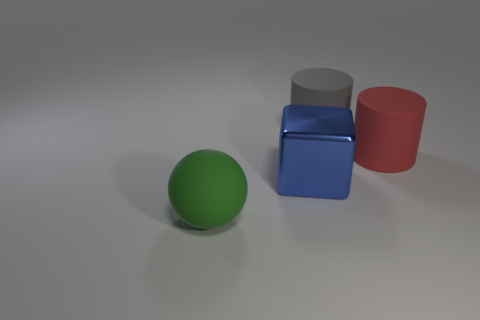Is there anything else that has the same material as the big block?
Provide a short and direct response. No. How many large objects are both behind the big rubber ball and in front of the red cylinder?
Ensure brevity in your answer.  1. What is the material of the large thing right of the big rubber object behind the red matte cylinder?
Provide a short and direct response. Rubber. What material is the large gray object that is the same shape as the large red rubber thing?
Keep it short and to the point. Rubber. Are any small purple metal cubes visible?
Offer a terse response. No. There is a big green object that is the same material as the big red thing; what shape is it?
Make the answer very short. Sphere. What material is the object in front of the big blue metallic cube?
Provide a short and direct response. Rubber. There is a rubber thing in front of the big red cylinder; is its color the same as the cube?
Offer a terse response. No. There is a rubber cylinder that is left of the cylinder to the right of the large gray cylinder; what is its size?
Your answer should be compact. Large. Is the number of rubber spheres to the right of the big metallic block greater than the number of brown things?
Your response must be concise. No. 